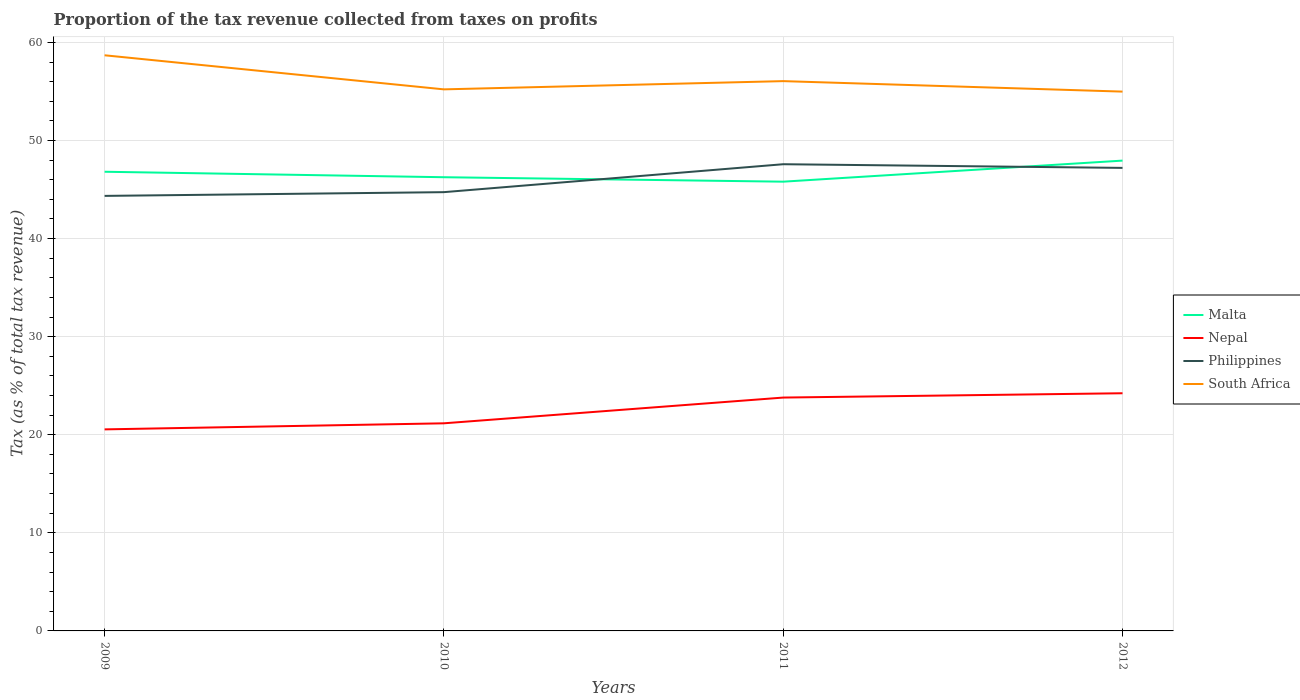How many different coloured lines are there?
Ensure brevity in your answer.  4. Is the number of lines equal to the number of legend labels?
Ensure brevity in your answer.  Yes. Across all years, what is the maximum proportion of the tax revenue collected in Philippines?
Your answer should be very brief. 44.35. What is the total proportion of the tax revenue collected in South Africa in the graph?
Your response must be concise. 2.63. What is the difference between the highest and the second highest proportion of the tax revenue collected in Malta?
Provide a succinct answer. 2.15. What is the difference between the highest and the lowest proportion of the tax revenue collected in Nepal?
Give a very brief answer. 2. Is the proportion of the tax revenue collected in Nepal strictly greater than the proportion of the tax revenue collected in South Africa over the years?
Provide a succinct answer. Yes. How many lines are there?
Make the answer very short. 4. What is the difference between two consecutive major ticks on the Y-axis?
Provide a short and direct response. 10. Where does the legend appear in the graph?
Offer a very short reply. Center right. How many legend labels are there?
Make the answer very short. 4. What is the title of the graph?
Your response must be concise. Proportion of the tax revenue collected from taxes on profits. Does "Low & middle income" appear as one of the legend labels in the graph?
Offer a terse response. No. What is the label or title of the Y-axis?
Offer a very short reply. Tax (as % of total tax revenue). What is the Tax (as % of total tax revenue) in Malta in 2009?
Offer a terse response. 46.81. What is the Tax (as % of total tax revenue) of Nepal in 2009?
Provide a short and direct response. 20.55. What is the Tax (as % of total tax revenue) of Philippines in 2009?
Provide a succinct answer. 44.35. What is the Tax (as % of total tax revenue) of South Africa in 2009?
Ensure brevity in your answer.  58.69. What is the Tax (as % of total tax revenue) in Malta in 2010?
Give a very brief answer. 46.25. What is the Tax (as % of total tax revenue) of Nepal in 2010?
Ensure brevity in your answer.  21.17. What is the Tax (as % of total tax revenue) of Philippines in 2010?
Ensure brevity in your answer.  44.73. What is the Tax (as % of total tax revenue) in South Africa in 2010?
Make the answer very short. 55.21. What is the Tax (as % of total tax revenue) in Malta in 2011?
Give a very brief answer. 45.8. What is the Tax (as % of total tax revenue) of Nepal in 2011?
Keep it short and to the point. 23.79. What is the Tax (as % of total tax revenue) in Philippines in 2011?
Keep it short and to the point. 47.58. What is the Tax (as % of total tax revenue) in South Africa in 2011?
Keep it short and to the point. 56.05. What is the Tax (as % of total tax revenue) in Malta in 2012?
Keep it short and to the point. 47.95. What is the Tax (as % of total tax revenue) in Nepal in 2012?
Make the answer very short. 24.23. What is the Tax (as % of total tax revenue) of Philippines in 2012?
Keep it short and to the point. 47.21. What is the Tax (as % of total tax revenue) of South Africa in 2012?
Keep it short and to the point. 54.98. Across all years, what is the maximum Tax (as % of total tax revenue) in Malta?
Ensure brevity in your answer.  47.95. Across all years, what is the maximum Tax (as % of total tax revenue) in Nepal?
Provide a short and direct response. 24.23. Across all years, what is the maximum Tax (as % of total tax revenue) of Philippines?
Provide a succinct answer. 47.58. Across all years, what is the maximum Tax (as % of total tax revenue) in South Africa?
Give a very brief answer. 58.69. Across all years, what is the minimum Tax (as % of total tax revenue) of Malta?
Make the answer very short. 45.8. Across all years, what is the minimum Tax (as % of total tax revenue) of Nepal?
Provide a succinct answer. 20.55. Across all years, what is the minimum Tax (as % of total tax revenue) in Philippines?
Provide a short and direct response. 44.35. Across all years, what is the minimum Tax (as % of total tax revenue) of South Africa?
Keep it short and to the point. 54.98. What is the total Tax (as % of total tax revenue) of Malta in the graph?
Your response must be concise. 186.82. What is the total Tax (as % of total tax revenue) of Nepal in the graph?
Provide a succinct answer. 89.74. What is the total Tax (as % of total tax revenue) in Philippines in the graph?
Ensure brevity in your answer.  183.87. What is the total Tax (as % of total tax revenue) of South Africa in the graph?
Offer a very short reply. 224.94. What is the difference between the Tax (as % of total tax revenue) of Malta in 2009 and that in 2010?
Your answer should be very brief. 0.56. What is the difference between the Tax (as % of total tax revenue) in Nepal in 2009 and that in 2010?
Give a very brief answer. -0.62. What is the difference between the Tax (as % of total tax revenue) of Philippines in 2009 and that in 2010?
Offer a terse response. -0.38. What is the difference between the Tax (as % of total tax revenue) of South Africa in 2009 and that in 2010?
Provide a short and direct response. 3.47. What is the difference between the Tax (as % of total tax revenue) in Malta in 2009 and that in 2011?
Make the answer very short. 1.01. What is the difference between the Tax (as % of total tax revenue) in Nepal in 2009 and that in 2011?
Offer a terse response. -3.24. What is the difference between the Tax (as % of total tax revenue) of Philippines in 2009 and that in 2011?
Your response must be concise. -3.23. What is the difference between the Tax (as % of total tax revenue) of South Africa in 2009 and that in 2011?
Your response must be concise. 2.63. What is the difference between the Tax (as % of total tax revenue) in Malta in 2009 and that in 2012?
Your response must be concise. -1.14. What is the difference between the Tax (as % of total tax revenue) in Nepal in 2009 and that in 2012?
Provide a succinct answer. -3.68. What is the difference between the Tax (as % of total tax revenue) of Philippines in 2009 and that in 2012?
Ensure brevity in your answer.  -2.85. What is the difference between the Tax (as % of total tax revenue) of South Africa in 2009 and that in 2012?
Your answer should be very brief. 3.7. What is the difference between the Tax (as % of total tax revenue) of Malta in 2010 and that in 2011?
Give a very brief answer. 0.45. What is the difference between the Tax (as % of total tax revenue) in Nepal in 2010 and that in 2011?
Give a very brief answer. -2.62. What is the difference between the Tax (as % of total tax revenue) in Philippines in 2010 and that in 2011?
Ensure brevity in your answer.  -2.85. What is the difference between the Tax (as % of total tax revenue) in South Africa in 2010 and that in 2011?
Offer a terse response. -0.84. What is the difference between the Tax (as % of total tax revenue) of Malta in 2010 and that in 2012?
Ensure brevity in your answer.  -1.69. What is the difference between the Tax (as % of total tax revenue) in Nepal in 2010 and that in 2012?
Make the answer very short. -3.06. What is the difference between the Tax (as % of total tax revenue) in Philippines in 2010 and that in 2012?
Make the answer very short. -2.47. What is the difference between the Tax (as % of total tax revenue) of South Africa in 2010 and that in 2012?
Keep it short and to the point. 0.23. What is the difference between the Tax (as % of total tax revenue) in Malta in 2011 and that in 2012?
Give a very brief answer. -2.15. What is the difference between the Tax (as % of total tax revenue) of Nepal in 2011 and that in 2012?
Ensure brevity in your answer.  -0.44. What is the difference between the Tax (as % of total tax revenue) of Philippines in 2011 and that in 2012?
Make the answer very short. 0.37. What is the difference between the Tax (as % of total tax revenue) in South Africa in 2011 and that in 2012?
Offer a very short reply. 1.07. What is the difference between the Tax (as % of total tax revenue) of Malta in 2009 and the Tax (as % of total tax revenue) of Nepal in 2010?
Provide a succinct answer. 25.65. What is the difference between the Tax (as % of total tax revenue) of Malta in 2009 and the Tax (as % of total tax revenue) of Philippines in 2010?
Your answer should be very brief. 2.08. What is the difference between the Tax (as % of total tax revenue) in Malta in 2009 and the Tax (as % of total tax revenue) in South Africa in 2010?
Provide a succinct answer. -8.4. What is the difference between the Tax (as % of total tax revenue) of Nepal in 2009 and the Tax (as % of total tax revenue) of Philippines in 2010?
Keep it short and to the point. -24.19. What is the difference between the Tax (as % of total tax revenue) of Nepal in 2009 and the Tax (as % of total tax revenue) of South Africa in 2010?
Offer a terse response. -34.66. What is the difference between the Tax (as % of total tax revenue) of Philippines in 2009 and the Tax (as % of total tax revenue) of South Africa in 2010?
Give a very brief answer. -10.86. What is the difference between the Tax (as % of total tax revenue) in Malta in 2009 and the Tax (as % of total tax revenue) in Nepal in 2011?
Provide a succinct answer. 23.02. What is the difference between the Tax (as % of total tax revenue) in Malta in 2009 and the Tax (as % of total tax revenue) in Philippines in 2011?
Provide a succinct answer. -0.77. What is the difference between the Tax (as % of total tax revenue) of Malta in 2009 and the Tax (as % of total tax revenue) of South Africa in 2011?
Your response must be concise. -9.24. What is the difference between the Tax (as % of total tax revenue) in Nepal in 2009 and the Tax (as % of total tax revenue) in Philippines in 2011?
Make the answer very short. -27.03. What is the difference between the Tax (as % of total tax revenue) in Nepal in 2009 and the Tax (as % of total tax revenue) in South Africa in 2011?
Your answer should be compact. -35.5. What is the difference between the Tax (as % of total tax revenue) of Philippines in 2009 and the Tax (as % of total tax revenue) of South Africa in 2011?
Give a very brief answer. -11.7. What is the difference between the Tax (as % of total tax revenue) in Malta in 2009 and the Tax (as % of total tax revenue) in Nepal in 2012?
Keep it short and to the point. 22.58. What is the difference between the Tax (as % of total tax revenue) in Malta in 2009 and the Tax (as % of total tax revenue) in Philippines in 2012?
Offer a very short reply. -0.39. What is the difference between the Tax (as % of total tax revenue) of Malta in 2009 and the Tax (as % of total tax revenue) of South Africa in 2012?
Keep it short and to the point. -8.17. What is the difference between the Tax (as % of total tax revenue) of Nepal in 2009 and the Tax (as % of total tax revenue) of Philippines in 2012?
Offer a terse response. -26.66. What is the difference between the Tax (as % of total tax revenue) in Nepal in 2009 and the Tax (as % of total tax revenue) in South Africa in 2012?
Offer a very short reply. -34.44. What is the difference between the Tax (as % of total tax revenue) in Philippines in 2009 and the Tax (as % of total tax revenue) in South Africa in 2012?
Give a very brief answer. -10.63. What is the difference between the Tax (as % of total tax revenue) in Malta in 2010 and the Tax (as % of total tax revenue) in Nepal in 2011?
Ensure brevity in your answer.  22.46. What is the difference between the Tax (as % of total tax revenue) in Malta in 2010 and the Tax (as % of total tax revenue) in Philippines in 2011?
Keep it short and to the point. -1.33. What is the difference between the Tax (as % of total tax revenue) in Malta in 2010 and the Tax (as % of total tax revenue) in South Africa in 2011?
Provide a short and direct response. -9.8. What is the difference between the Tax (as % of total tax revenue) in Nepal in 2010 and the Tax (as % of total tax revenue) in Philippines in 2011?
Your answer should be very brief. -26.41. What is the difference between the Tax (as % of total tax revenue) of Nepal in 2010 and the Tax (as % of total tax revenue) of South Africa in 2011?
Provide a succinct answer. -34.89. What is the difference between the Tax (as % of total tax revenue) in Philippines in 2010 and the Tax (as % of total tax revenue) in South Africa in 2011?
Your answer should be very brief. -11.32. What is the difference between the Tax (as % of total tax revenue) of Malta in 2010 and the Tax (as % of total tax revenue) of Nepal in 2012?
Your answer should be compact. 22.02. What is the difference between the Tax (as % of total tax revenue) in Malta in 2010 and the Tax (as % of total tax revenue) in Philippines in 2012?
Offer a terse response. -0.95. What is the difference between the Tax (as % of total tax revenue) in Malta in 2010 and the Tax (as % of total tax revenue) in South Africa in 2012?
Offer a very short reply. -8.73. What is the difference between the Tax (as % of total tax revenue) in Nepal in 2010 and the Tax (as % of total tax revenue) in Philippines in 2012?
Give a very brief answer. -26.04. What is the difference between the Tax (as % of total tax revenue) of Nepal in 2010 and the Tax (as % of total tax revenue) of South Africa in 2012?
Your response must be concise. -33.82. What is the difference between the Tax (as % of total tax revenue) of Philippines in 2010 and the Tax (as % of total tax revenue) of South Africa in 2012?
Your answer should be compact. -10.25. What is the difference between the Tax (as % of total tax revenue) of Malta in 2011 and the Tax (as % of total tax revenue) of Nepal in 2012?
Keep it short and to the point. 21.57. What is the difference between the Tax (as % of total tax revenue) of Malta in 2011 and the Tax (as % of total tax revenue) of Philippines in 2012?
Keep it short and to the point. -1.4. What is the difference between the Tax (as % of total tax revenue) of Malta in 2011 and the Tax (as % of total tax revenue) of South Africa in 2012?
Provide a succinct answer. -9.18. What is the difference between the Tax (as % of total tax revenue) in Nepal in 2011 and the Tax (as % of total tax revenue) in Philippines in 2012?
Give a very brief answer. -23.42. What is the difference between the Tax (as % of total tax revenue) of Nepal in 2011 and the Tax (as % of total tax revenue) of South Africa in 2012?
Provide a succinct answer. -31.19. What is the difference between the Tax (as % of total tax revenue) of Philippines in 2011 and the Tax (as % of total tax revenue) of South Africa in 2012?
Provide a succinct answer. -7.4. What is the average Tax (as % of total tax revenue) in Malta per year?
Offer a terse response. 46.7. What is the average Tax (as % of total tax revenue) of Nepal per year?
Give a very brief answer. 22.43. What is the average Tax (as % of total tax revenue) of Philippines per year?
Your response must be concise. 45.97. What is the average Tax (as % of total tax revenue) of South Africa per year?
Provide a short and direct response. 56.23. In the year 2009, what is the difference between the Tax (as % of total tax revenue) in Malta and Tax (as % of total tax revenue) in Nepal?
Provide a short and direct response. 26.27. In the year 2009, what is the difference between the Tax (as % of total tax revenue) in Malta and Tax (as % of total tax revenue) in Philippines?
Your response must be concise. 2.46. In the year 2009, what is the difference between the Tax (as % of total tax revenue) in Malta and Tax (as % of total tax revenue) in South Africa?
Offer a terse response. -11.87. In the year 2009, what is the difference between the Tax (as % of total tax revenue) of Nepal and Tax (as % of total tax revenue) of Philippines?
Provide a short and direct response. -23.8. In the year 2009, what is the difference between the Tax (as % of total tax revenue) of Nepal and Tax (as % of total tax revenue) of South Africa?
Your answer should be very brief. -38.14. In the year 2009, what is the difference between the Tax (as % of total tax revenue) in Philippines and Tax (as % of total tax revenue) in South Africa?
Your answer should be very brief. -14.34. In the year 2010, what is the difference between the Tax (as % of total tax revenue) in Malta and Tax (as % of total tax revenue) in Nepal?
Ensure brevity in your answer.  25.09. In the year 2010, what is the difference between the Tax (as % of total tax revenue) in Malta and Tax (as % of total tax revenue) in Philippines?
Provide a succinct answer. 1.52. In the year 2010, what is the difference between the Tax (as % of total tax revenue) of Malta and Tax (as % of total tax revenue) of South Africa?
Keep it short and to the point. -8.96. In the year 2010, what is the difference between the Tax (as % of total tax revenue) in Nepal and Tax (as % of total tax revenue) in Philippines?
Provide a short and direct response. -23.57. In the year 2010, what is the difference between the Tax (as % of total tax revenue) of Nepal and Tax (as % of total tax revenue) of South Africa?
Your answer should be compact. -34.05. In the year 2010, what is the difference between the Tax (as % of total tax revenue) in Philippines and Tax (as % of total tax revenue) in South Africa?
Offer a very short reply. -10.48. In the year 2011, what is the difference between the Tax (as % of total tax revenue) of Malta and Tax (as % of total tax revenue) of Nepal?
Your answer should be very brief. 22.01. In the year 2011, what is the difference between the Tax (as % of total tax revenue) of Malta and Tax (as % of total tax revenue) of Philippines?
Provide a succinct answer. -1.78. In the year 2011, what is the difference between the Tax (as % of total tax revenue) in Malta and Tax (as % of total tax revenue) in South Africa?
Make the answer very short. -10.25. In the year 2011, what is the difference between the Tax (as % of total tax revenue) of Nepal and Tax (as % of total tax revenue) of Philippines?
Ensure brevity in your answer.  -23.79. In the year 2011, what is the difference between the Tax (as % of total tax revenue) of Nepal and Tax (as % of total tax revenue) of South Africa?
Ensure brevity in your answer.  -32.26. In the year 2011, what is the difference between the Tax (as % of total tax revenue) in Philippines and Tax (as % of total tax revenue) in South Africa?
Ensure brevity in your answer.  -8.47. In the year 2012, what is the difference between the Tax (as % of total tax revenue) in Malta and Tax (as % of total tax revenue) in Nepal?
Your response must be concise. 23.72. In the year 2012, what is the difference between the Tax (as % of total tax revenue) of Malta and Tax (as % of total tax revenue) of Philippines?
Your response must be concise. 0.74. In the year 2012, what is the difference between the Tax (as % of total tax revenue) of Malta and Tax (as % of total tax revenue) of South Africa?
Keep it short and to the point. -7.04. In the year 2012, what is the difference between the Tax (as % of total tax revenue) in Nepal and Tax (as % of total tax revenue) in Philippines?
Ensure brevity in your answer.  -22.97. In the year 2012, what is the difference between the Tax (as % of total tax revenue) of Nepal and Tax (as % of total tax revenue) of South Africa?
Provide a succinct answer. -30.75. In the year 2012, what is the difference between the Tax (as % of total tax revenue) in Philippines and Tax (as % of total tax revenue) in South Africa?
Give a very brief answer. -7.78. What is the ratio of the Tax (as % of total tax revenue) of Malta in 2009 to that in 2010?
Make the answer very short. 1.01. What is the ratio of the Tax (as % of total tax revenue) of Nepal in 2009 to that in 2010?
Your answer should be very brief. 0.97. What is the ratio of the Tax (as % of total tax revenue) in Philippines in 2009 to that in 2010?
Your response must be concise. 0.99. What is the ratio of the Tax (as % of total tax revenue) in South Africa in 2009 to that in 2010?
Offer a terse response. 1.06. What is the ratio of the Tax (as % of total tax revenue) in Malta in 2009 to that in 2011?
Your response must be concise. 1.02. What is the ratio of the Tax (as % of total tax revenue) in Nepal in 2009 to that in 2011?
Provide a short and direct response. 0.86. What is the ratio of the Tax (as % of total tax revenue) of Philippines in 2009 to that in 2011?
Provide a short and direct response. 0.93. What is the ratio of the Tax (as % of total tax revenue) in South Africa in 2009 to that in 2011?
Give a very brief answer. 1.05. What is the ratio of the Tax (as % of total tax revenue) of Malta in 2009 to that in 2012?
Your response must be concise. 0.98. What is the ratio of the Tax (as % of total tax revenue) of Nepal in 2009 to that in 2012?
Keep it short and to the point. 0.85. What is the ratio of the Tax (as % of total tax revenue) in Philippines in 2009 to that in 2012?
Make the answer very short. 0.94. What is the ratio of the Tax (as % of total tax revenue) of South Africa in 2009 to that in 2012?
Keep it short and to the point. 1.07. What is the ratio of the Tax (as % of total tax revenue) in Malta in 2010 to that in 2011?
Your answer should be very brief. 1.01. What is the ratio of the Tax (as % of total tax revenue) of Nepal in 2010 to that in 2011?
Your answer should be very brief. 0.89. What is the ratio of the Tax (as % of total tax revenue) in Philippines in 2010 to that in 2011?
Your answer should be very brief. 0.94. What is the ratio of the Tax (as % of total tax revenue) in Malta in 2010 to that in 2012?
Ensure brevity in your answer.  0.96. What is the ratio of the Tax (as % of total tax revenue) in Nepal in 2010 to that in 2012?
Give a very brief answer. 0.87. What is the ratio of the Tax (as % of total tax revenue) in Philippines in 2010 to that in 2012?
Provide a short and direct response. 0.95. What is the ratio of the Tax (as % of total tax revenue) in South Africa in 2010 to that in 2012?
Make the answer very short. 1. What is the ratio of the Tax (as % of total tax revenue) in Malta in 2011 to that in 2012?
Offer a terse response. 0.96. What is the ratio of the Tax (as % of total tax revenue) of Nepal in 2011 to that in 2012?
Offer a very short reply. 0.98. What is the ratio of the Tax (as % of total tax revenue) of Philippines in 2011 to that in 2012?
Offer a very short reply. 1.01. What is the ratio of the Tax (as % of total tax revenue) in South Africa in 2011 to that in 2012?
Offer a terse response. 1.02. What is the difference between the highest and the second highest Tax (as % of total tax revenue) in Malta?
Provide a succinct answer. 1.14. What is the difference between the highest and the second highest Tax (as % of total tax revenue) in Nepal?
Offer a terse response. 0.44. What is the difference between the highest and the second highest Tax (as % of total tax revenue) of Philippines?
Make the answer very short. 0.37. What is the difference between the highest and the second highest Tax (as % of total tax revenue) of South Africa?
Offer a very short reply. 2.63. What is the difference between the highest and the lowest Tax (as % of total tax revenue) in Malta?
Provide a short and direct response. 2.15. What is the difference between the highest and the lowest Tax (as % of total tax revenue) of Nepal?
Offer a terse response. 3.68. What is the difference between the highest and the lowest Tax (as % of total tax revenue) of Philippines?
Your answer should be very brief. 3.23. What is the difference between the highest and the lowest Tax (as % of total tax revenue) of South Africa?
Offer a terse response. 3.7. 